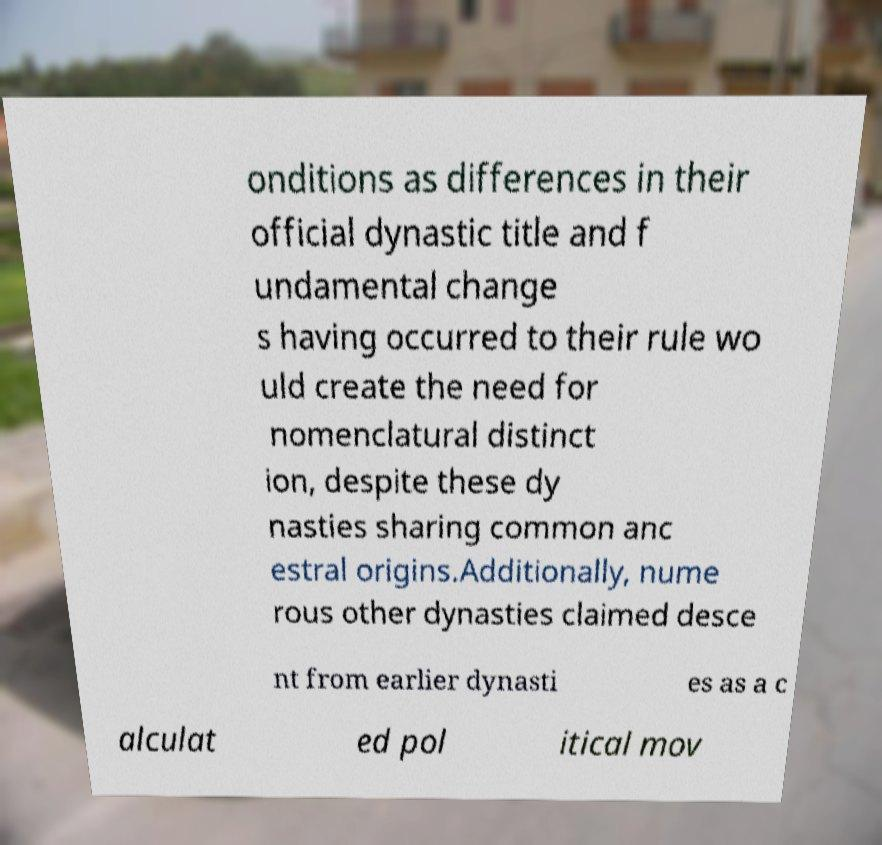Please read and relay the text visible in this image. What does it say? onditions as differences in their official dynastic title and f undamental change s having occurred to their rule wo uld create the need for nomenclatural distinct ion, despite these dy nasties sharing common anc estral origins.Additionally, nume rous other dynasties claimed desce nt from earlier dynasti es as a c alculat ed pol itical mov 